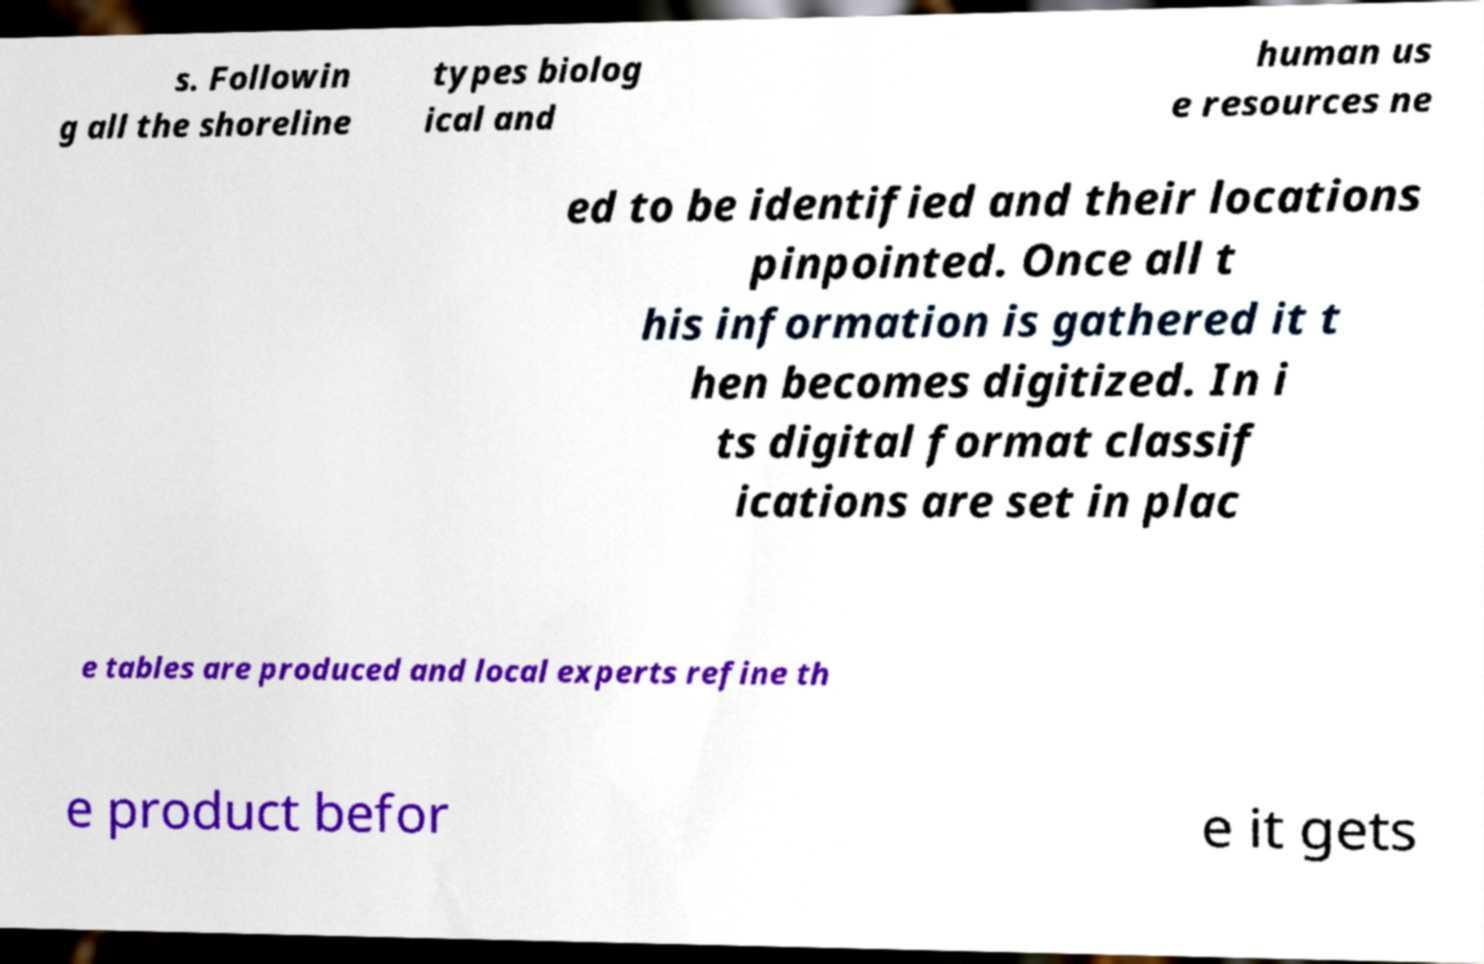There's text embedded in this image that I need extracted. Can you transcribe it verbatim? s. Followin g all the shoreline types biolog ical and human us e resources ne ed to be identified and their locations pinpointed. Once all t his information is gathered it t hen becomes digitized. In i ts digital format classif ications are set in plac e tables are produced and local experts refine th e product befor e it gets 